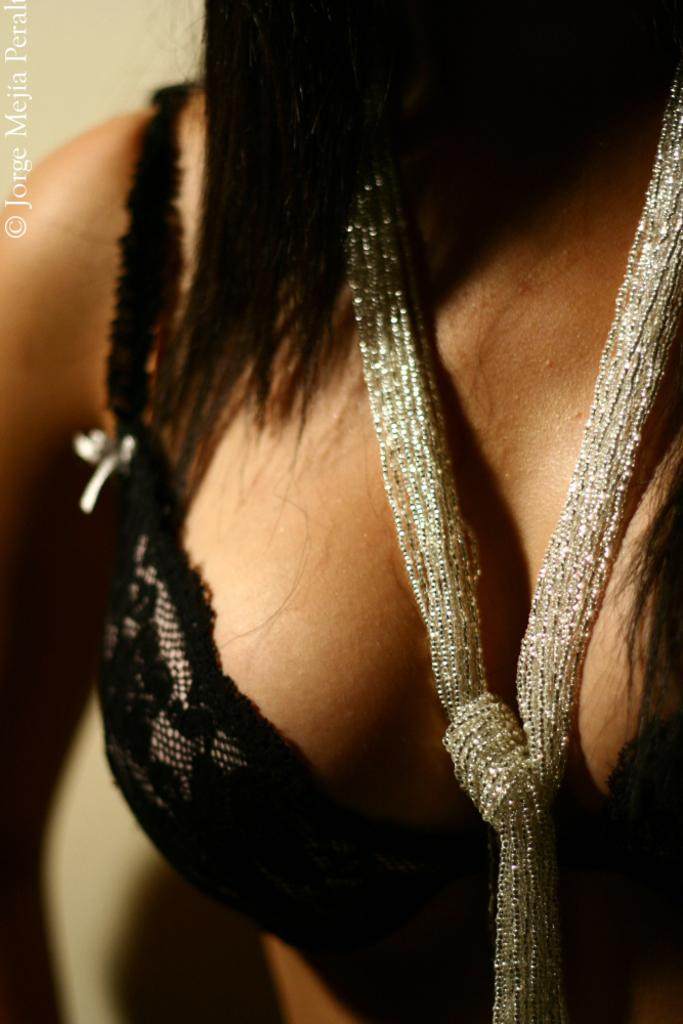Who is present in the image? There is a woman in the image. What is the woman wearing? The woman is wearing clothes and a scarf. Is there any additional information about the image? Yes, there is a watermark in the image. What type of slip can be seen under the woman's clothing in the image? There is no slip visible under the woman's clothing in the image. What kind of eggnog is being served in the image? There is no eggnog present in the image. 